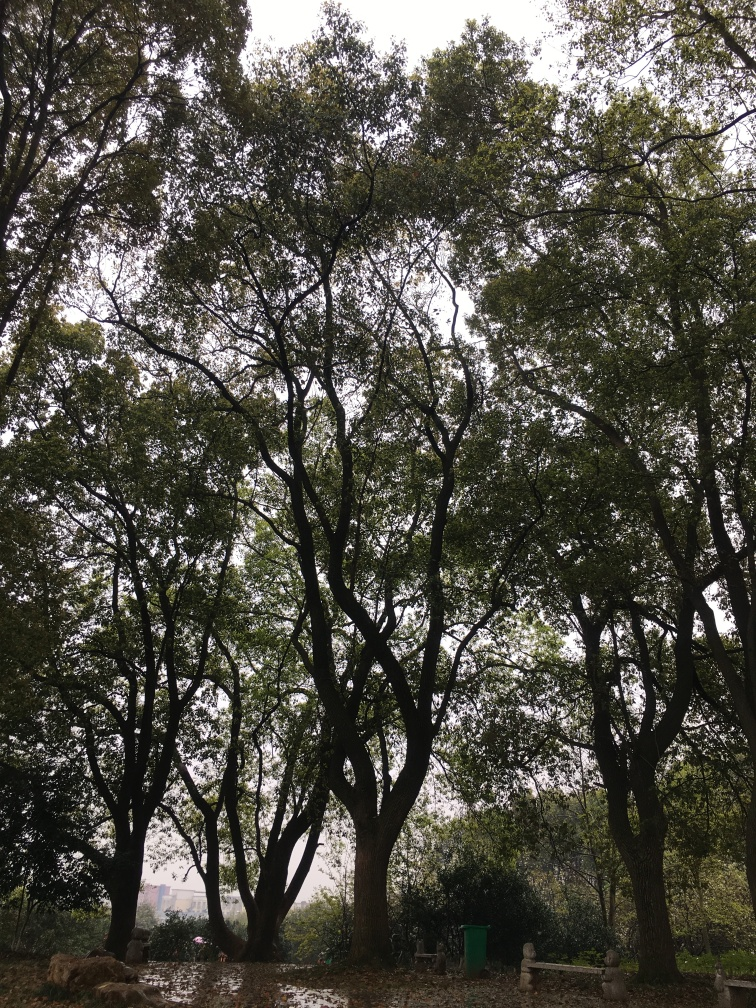Could this place be used for recreational activities? It certainly looks like an appealing spot for outdoor activities. The natural setting provides ample shade and seems suitable for leisurely walks, picnics, or just sitting and enjoying the tranquility of the surroundings. 